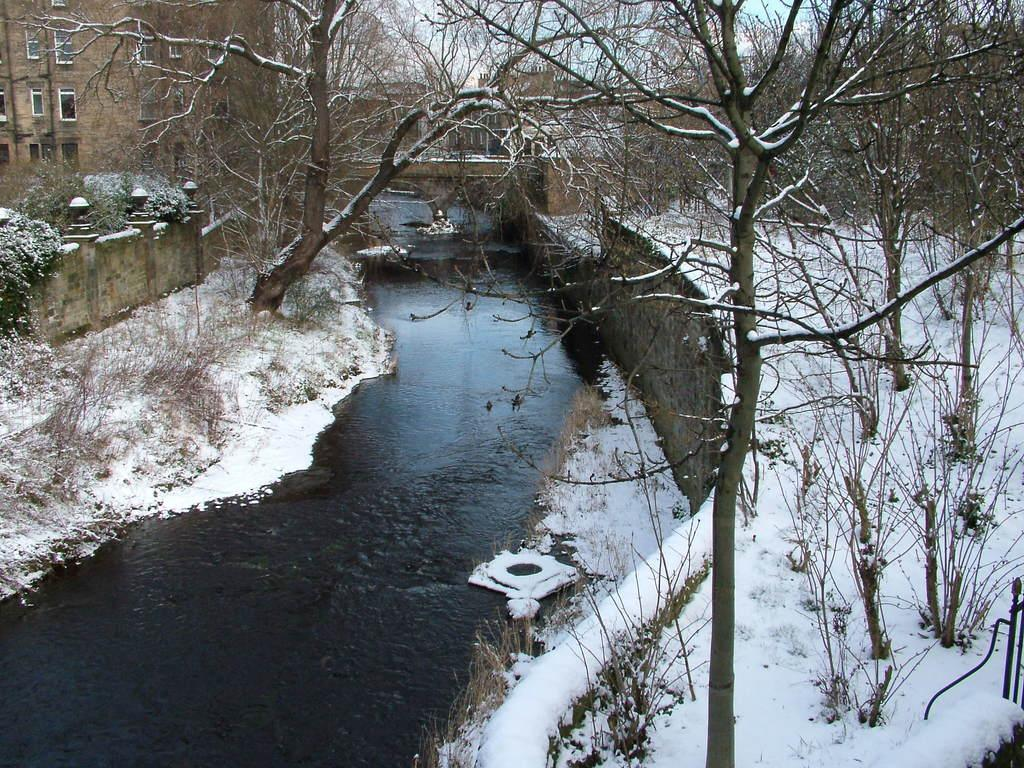What type of natural feature is present in the image? There is a lake in the image. What other natural elements can be seen in the image? There are trees in the image. Are there any man-made structures visible in the image? Yes, there is a building visible in the image. What is visible in the sky in the image? The sky is visible in the image. What type of weather condition is suggested by the presence of snow on the ground in the image? The presence of snow on the ground suggests that it is winter or a cold season. What type of secretary can be seen working at the building in the image? There is no secretary present in the image; it only shows a lake, trees, a building, the sky, and snow on the ground. 